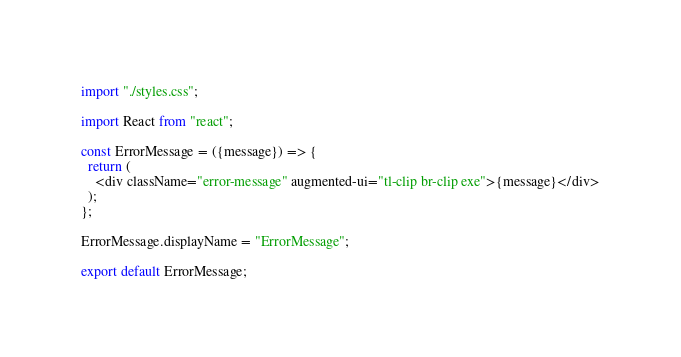<code> <loc_0><loc_0><loc_500><loc_500><_JavaScript_>import "./styles.css";

import React from "react";

const ErrorMessage = ({message}) => {
  return (
    <div className="error-message" augmented-ui="tl-clip br-clip exe">{message}</div>
  );
};

ErrorMessage.displayName = "ErrorMessage";

export default ErrorMessage;
</code> 